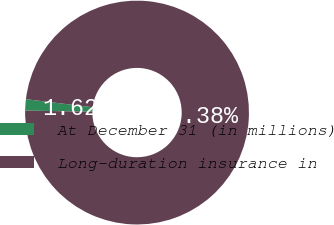<chart> <loc_0><loc_0><loc_500><loc_500><pie_chart><fcel>At December 31 (in millions)<fcel>Long-duration insurance in<nl><fcel>1.62%<fcel>98.38%<nl></chart> 